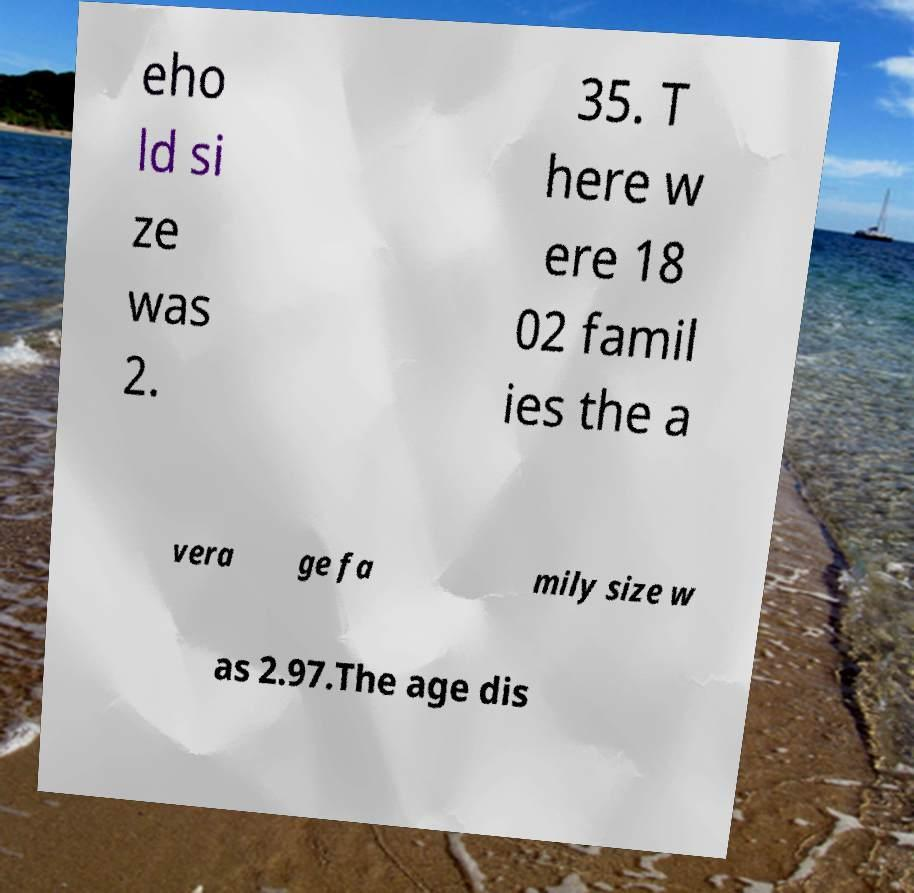Could you assist in decoding the text presented in this image and type it out clearly? eho ld si ze was 2. 35. T here w ere 18 02 famil ies the a vera ge fa mily size w as 2.97.The age dis 